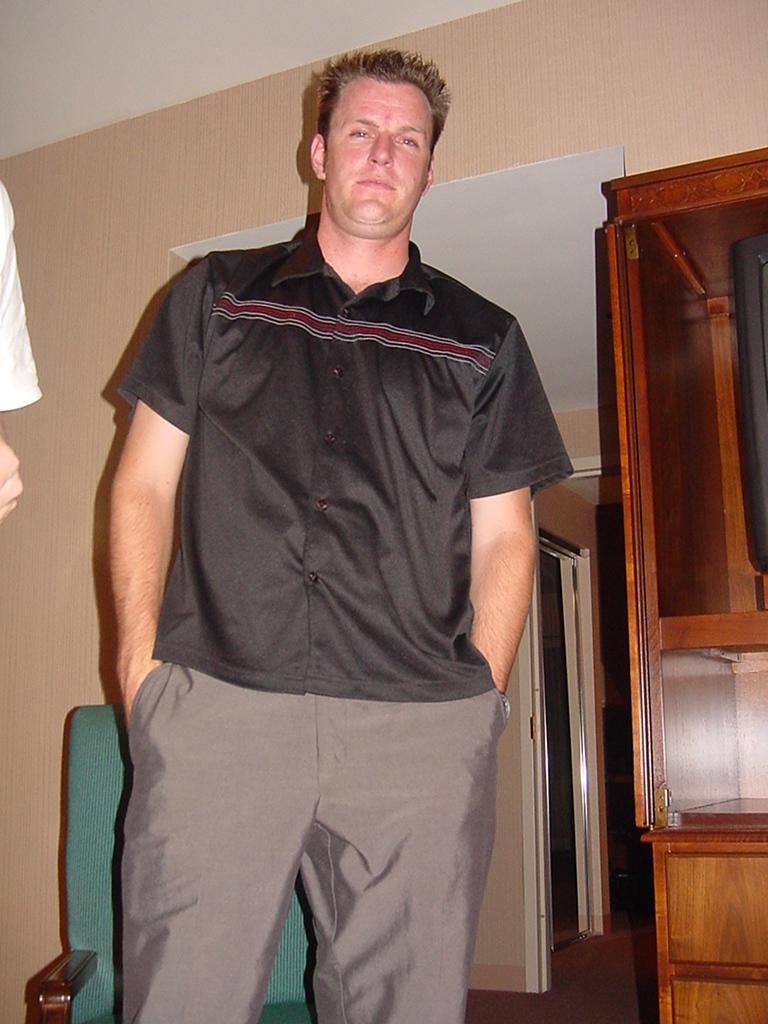How would you summarize this image in a sentence or two? This picture is clicked inside. In the center there was a man wearing black color shirt and standing on the ground. In the background we can see the wall, wooden cabinet, green color chair, roof and an object placed on the ground. On the left corner we can see the hand of a person. 